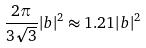Convert formula to latex. <formula><loc_0><loc_0><loc_500><loc_500>\frac { 2 \pi } { 3 \sqrt { 3 } } | b | ^ { 2 } \approx 1 . 2 1 | b | ^ { 2 }</formula> 